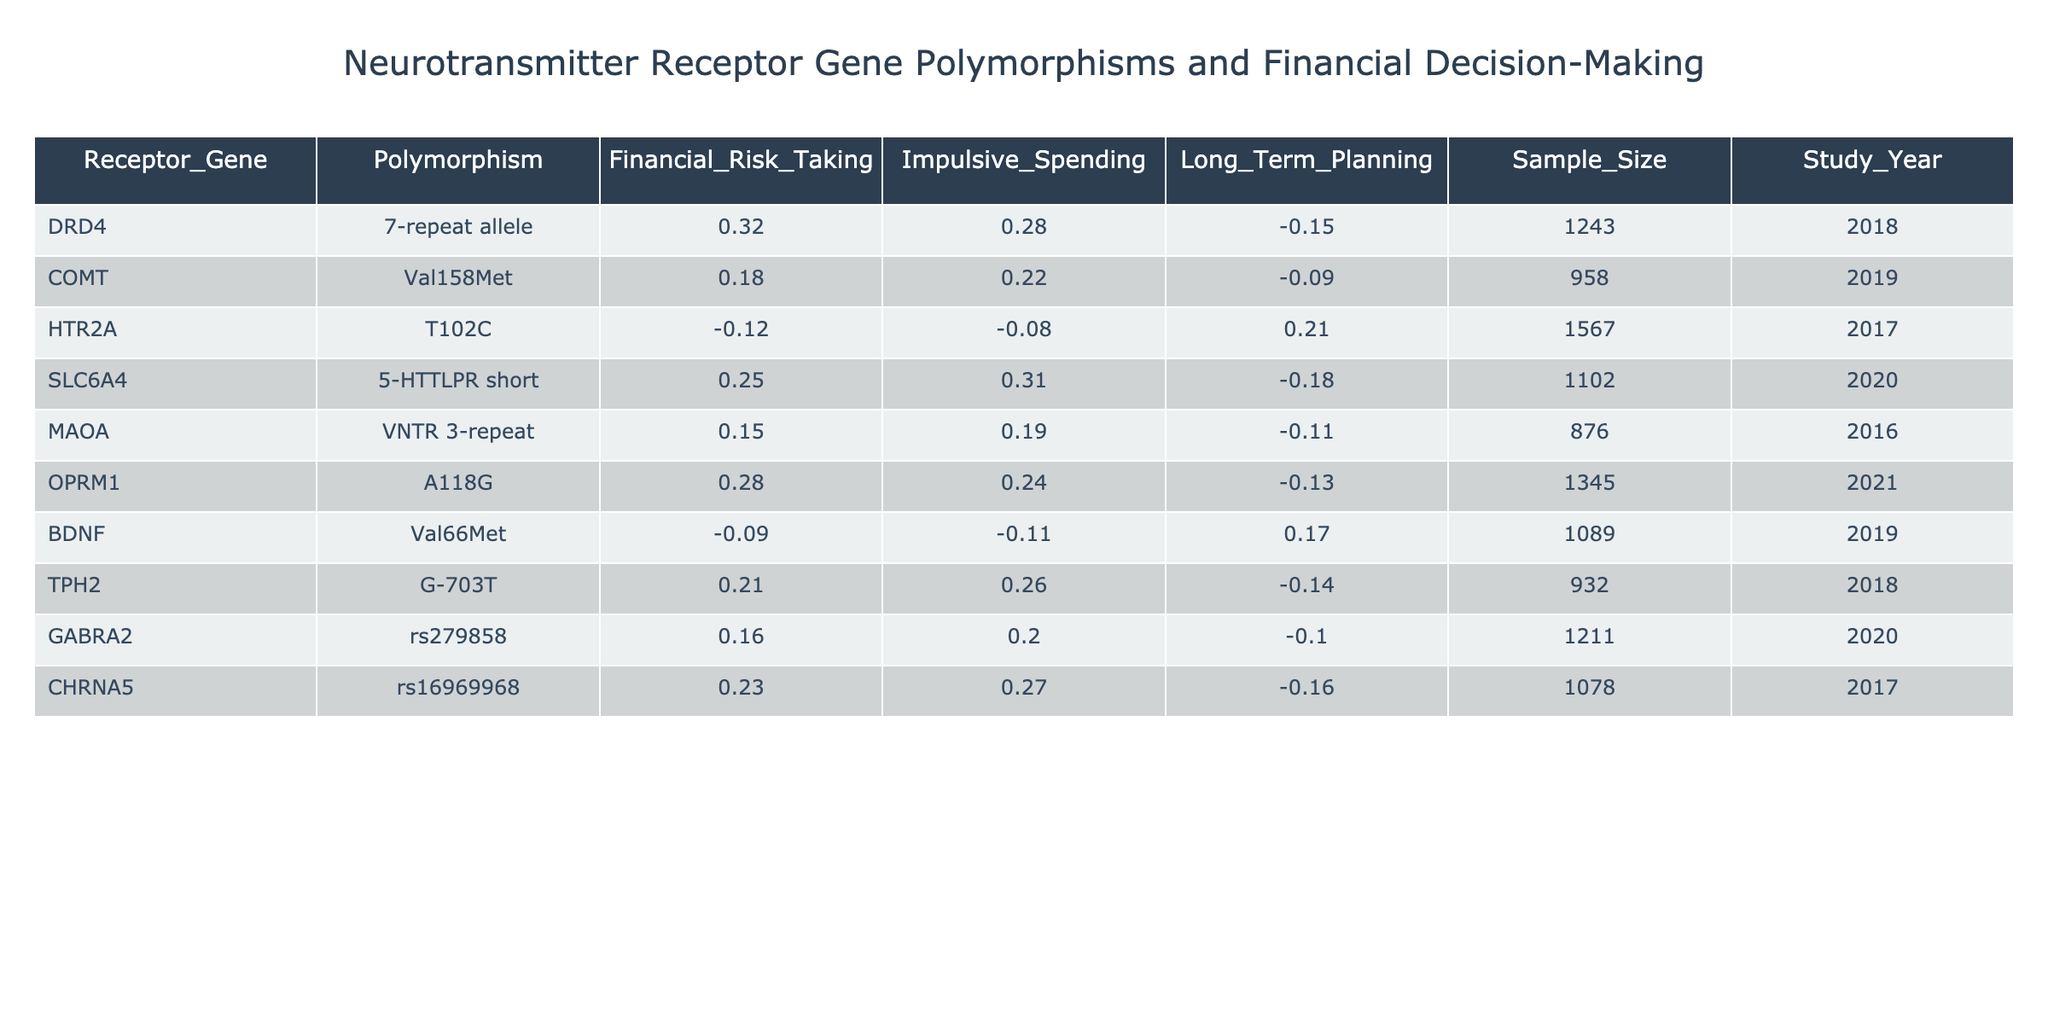What is the sample size for the DRD4 gene? The table lists the sample size corresponding to the DRD4 gene in the "Sample_Size" column, which shows a value of 1243 for this polymorphism.
Answer: 1243 Which polymorphism is associated with the highest impulsive spending score? By examining the "Impulsive_Spending" column, the polymorphism with the highest score is the SLC6A4, which has a value of 0.31.
Answer: SLC6A4 What is the average financial risk-taking score of the genes listed in the table? First, we sum the financial risk-taking scores: 0.32 + 0.18 - 0.12 + 0.25 + 0.15 + 0.28 - 0.09 + 0.21 + 0.16 + 0.23 = 1.25. Next, we divide by the number of genes (10), which gives us an average of 1.25 / 10 = 0.125.
Answer: 0.125 Is there a polymorphism among the listed genes with a negative long-term planning score? By scanning the "Long_Term_Planning" column, we find three values that are negative: -0.15 for DRD4, -0.09 for COMT, and -0.18 for SLC6A4. Therefore, yes, there are polymorphisms with negative scores.
Answer: Yes What is the difference in impulsive spending scores between the highest and lowest scoring genes? The highest impulsive spending score is 0.31 (SLC6A4), and the lowest is -0.11 (BDNF). To find the difference, we calculate 0.31 - (-0.11) = 0.31 + 0.11 = 0.42.
Answer: 0.42 Which receptor gene polymorphism has the least negative effect on long-term planning? Looking through the "Long_Term_Planning" column, the polymorphism with the least negative score is COMT, which has a score of -0.09.
Answer: COMT How many polymorphisms have positive financial risk-taking scores? Examining the "Financial_Risk_Taking" column, we find that 6 out of the 10 polymorphisms have positive scores: DRD4, COMT, SLC6A4, OPRM1, TPH2, and CHRNA5.
Answer: 6 What is the trend in impulsive spending scores over the years of the studies conducted? To assess the trend, we look at the years and corresponding impulsive spending scores: 0.28 (2018, DRD4), 0.22 (2019, COMT), -0.08 (2017, HTR2A), 0.31 (2020, SLC6A4), 0.19 (2016, MAOA), 0.24 (2021, OPRM1), -0.11 (2019, BDNF), 0.26 (2018, TPH2), 0.20 (2020, GABRA2), and 0.27 (2017, CHRNA5). The trend shows fluctuations with no consistent increase or decrease.
Answer: Fluctuating trend Which receptor gene polymorphism has the highest score for long-term planning? The highest score for long-term planning is from the HTR2A polymorphism, which is 0.21.
Answer: HTR2A 